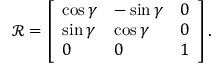<formula> <loc_0><loc_0><loc_500><loc_500>\mathcal { R } = \left [ \begin{array} { l l l } { \cos \gamma } & { - \sin \gamma } & { 0 } \\ { \sin \gamma } & { \cos \gamma } & { 0 } \\ { 0 } & { 0 } & { 1 } \end{array} \right ] .</formula> 